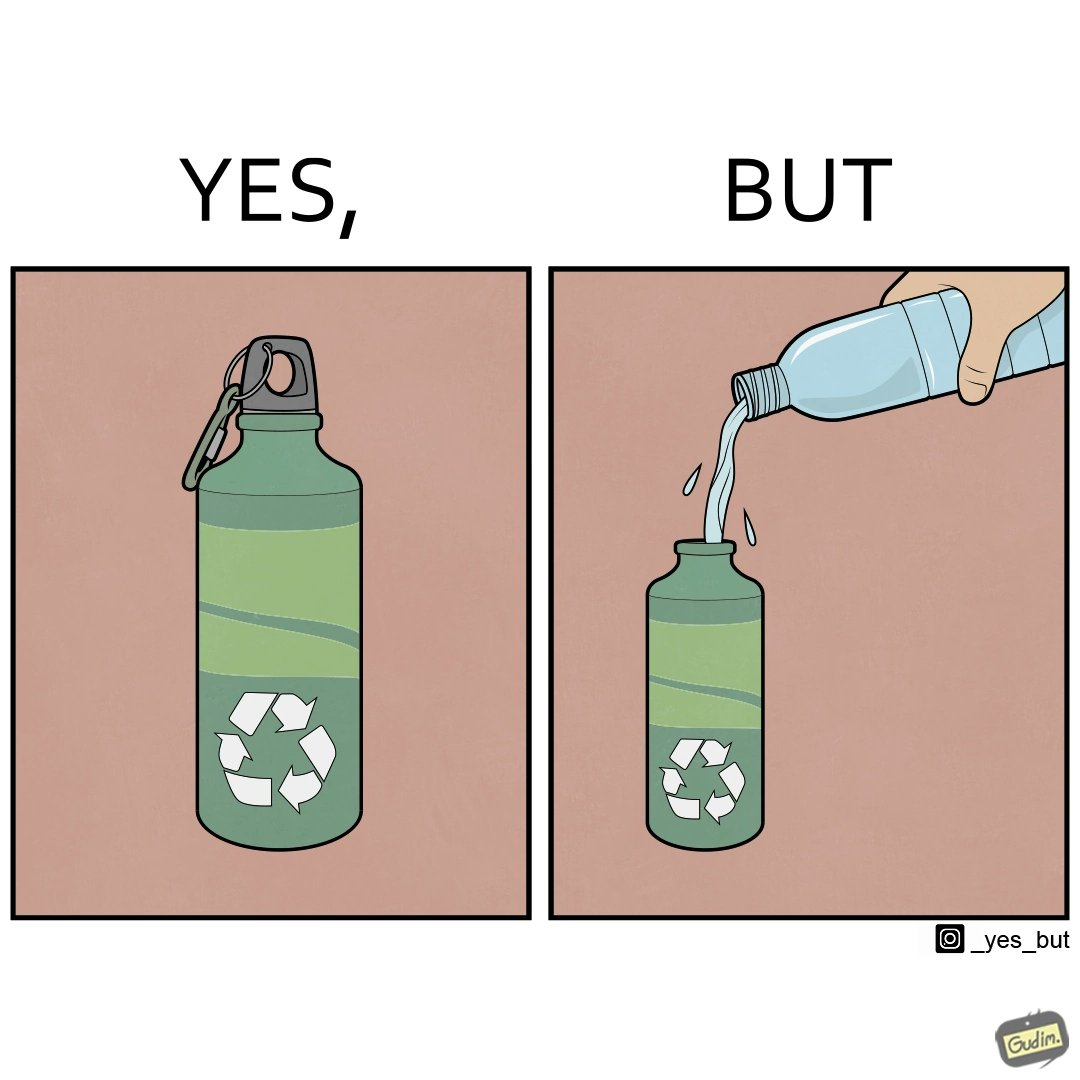What makes this image funny or satirical? The images are ironic since the metallic water bottle aims to be more sustainable as can be seen from the sign on the bottle but its user fills it with a plastic bottle which destroys its purpose 